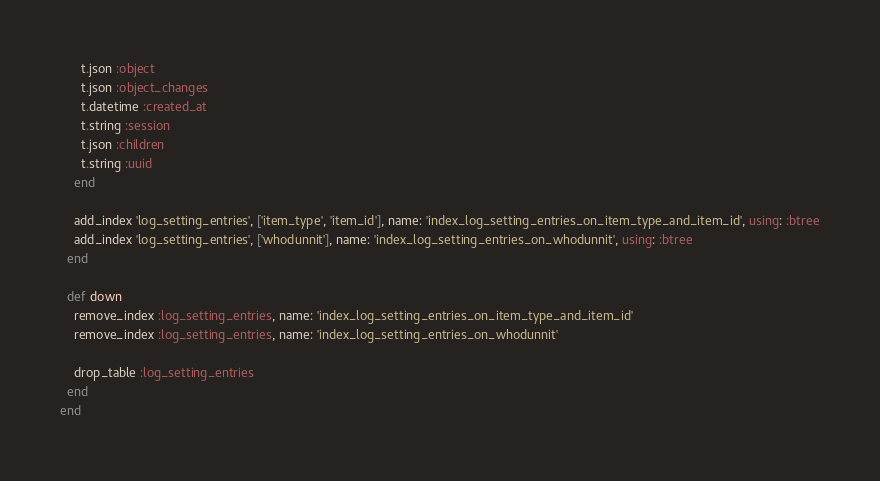Convert code to text. <code><loc_0><loc_0><loc_500><loc_500><_Ruby_>      t.json :object
      t.json :object_changes
      t.datetime :created_at
      t.string :session
      t.json :children
      t.string :uuid
    end

    add_index 'log_setting_entries', ['item_type', 'item_id'], name: 'index_log_setting_entries_on_item_type_and_item_id', using: :btree
    add_index 'log_setting_entries', ['whodunnit'], name: 'index_log_setting_entries_on_whodunnit', using: :btree
  end

  def down
    remove_index :log_setting_entries, name: 'index_log_setting_entries_on_item_type_and_item_id'
    remove_index :log_setting_entries, name: 'index_log_setting_entries_on_whodunnit'

    drop_table :log_setting_entries
  end
end
</code> 